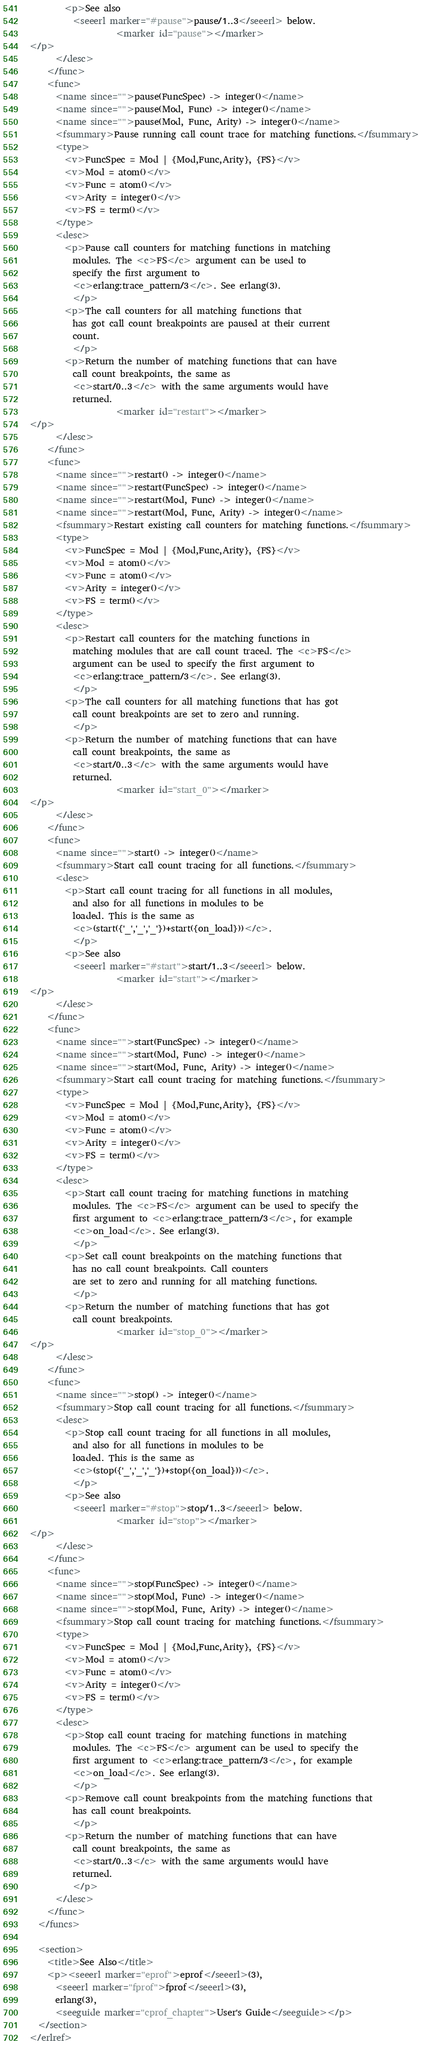Convert code to text. <code><loc_0><loc_0><loc_500><loc_500><_XML_>        <p>See also 
          <seeerl marker="#pause">pause/1..3</seeerl> below.
                    <marker id="pause"></marker>
</p>
      </desc>
    </func>
    <func>
      <name since="">pause(FuncSpec) -> integer()</name>
      <name since="">pause(Mod, Func) -> integer()</name>
      <name since="">pause(Mod, Func, Arity) -> integer()</name>
      <fsummary>Pause running call count trace for matching functions.</fsummary>
      <type>
        <v>FuncSpec = Mod | {Mod,Func,Arity}, {FS}</v>
        <v>Mod = atom()</v>
        <v>Func = atom()</v>
        <v>Arity = integer()</v>
        <v>FS = term()</v>
      </type>
      <desc>
        <p>Pause call counters for matching functions in matching 
          modules. The <c>FS</c> argument can be used to
          specify the first argument to
          <c>erlang:trace_pattern/3</c>. See erlang(3). 
          </p>
        <p>The call counters for all matching functions that
          has got call count breakpoints are paused at their current
          count. 
          </p>
        <p>Return the number of matching functions that can have
          call count breakpoints, the same as
          <c>start/0..3</c> with the same arguments would have
          returned. 
                    <marker id="restart"></marker>
</p>
      </desc>
    </func>
    <func>
      <name since="">restart() -> integer()</name>
      <name since="">restart(FuncSpec) -> integer()</name>
      <name since="">restart(Mod, Func) -> integer()</name>
      <name since="">restart(Mod, Func, Arity) -> integer()</name>
      <fsummary>Restart existing call counters for matching functions.</fsummary>
      <type>
        <v>FuncSpec = Mod | {Mod,Func,Arity}, {FS}</v>
        <v>Mod = atom()</v>
        <v>Func = atom()</v>
        <v>Arity = integer()</v>
        <v>FS = term()</v>
      </type>
      <desc>
        <p>Restart call counters for the matching functions in
          matching modules that are call count traced. The <c>FS</c>
          argument can be used to specify the first argument to
          <c>erlang:trace_pattern/3</c>. See erlang(3).
          </p>
        <p>The call counters for all matching functions that has got
          call count breakpoints are set to zero and running.
          </p>
        <p>Return the number of matching functions that can have
          call count breakpoints, the same as
          <c>start/0..3</c> with the same arguments would have
          returned. 
                    <marker id="start_0"></marker>
</p>
      </desc>
    </func>
    <func>
      <name since="">start() -> integer()</name>
      <fsummary>Start call count tracing for all functions.</fsummary>
      <desc>
        <p>Start call count tracing for all functions in all modules, 
          and also for all functions in modules to be
          loaded. This is the same as 
          <c>(start({'_','_','_'})+start({on_load}))</c>.
          </p>
        <p>See also 
          <seeerl marker="#start">start/1..3</seeerl> below.
                    <marker id="start"></marker>
</p>
      </desc>
    </func>
    <func>
      <name since="">start(FuncSpec) -> integer()</name>
      <name since="">start(Mod, Func) -> integer()</name>
      <name since="">start(Mod, Func, Arity) -> integer()</name>
      <fsummary>Start call count tracing for matching functions.</fsummary>
      <type>
        <v>FuncSpec = Mod | {Mod,Func,Arity}, {FS}</v>
        <v>Mod = atom()</v>
        <v>Func = atom()</v>
        <v>Arity = integer()</v>
        <v>FS = term()</v>
      </type>
      <desc>
        <p>Start call count tracing for matching functions in matching 
          modules. The <c>FS</c> argument can be used to specify the
          first argument to <c>erlang:trace_pattern/3</c>, for example
          <c>on_load</c>. See erlang(3). 
          </p>
        <p>Set call count breakpoints on the matching functions that
          has no call count breakpoints. Call counters 
          are set to zero and running for all matching functions.
          </p>
        <p>Return the number of matching functions that has got
          call count breakpoints.
                    <marker id="stop_0"></marker>
</p>
      </desc>
    </func>
    <func>
      <name since="">stop() -> integer()</name>
      <fsummary>Stop call count tracing for all functions.</fsummary>
      <desc>
        <p>Stop call count tracing for all functions in all modules, 
          and also for all functions in modules to be
          loaded. This is the same as 
          <c>(stop({'_','_','_'})+stop({on_load}))</c>.
          </p>
        <p>See also 
          <seeerl marker="#stop">stop/1..3</seeerl> below.
                    <marker id="stop"></marker>
</p>
      </desc>
    </func>
    <func>
      <name since="">stop(FuncSpec) -> integer()</name>
      <name since="">stop(Mod, Func) -> integer()</name>
      <name since="">stop(Mod, Func, Arity) -> integer()</name>
      <fsummary>Stop call count tracing for matching functions.</fsummary>
      <type>
        <v>FuncSpec = Mod | {Mod,Func,Arity}, {FS}</v>
        <v>Mod = atom()</v>
        <v>Func = atom()</v>
        <v>Arity = integer()</v>
        <v>FS = term()</v>
      </type>
      <desc>
        <p>Stop call count tracing for matching functions in matching 
          modules. The <c>FS</c> argument can be used to specify the
          first argument to <c>erlang:trace_pattern/3</c>, for example
          <c>on_load</c>. See erlang(3). 
          </p>
        <p>Remove call count breakpoints from the matching functions that
          has call count breakpoints.
          </p>
        <p>Return the number of matching functions that can have
          call count breakpoints, the same as
          <c>start/0..3</c> with the same arguments would have
          returned. 
          </p>
      </desc>
    </func>
  </funcs>

  <section>
    <title>See Also</title>
    <p><seeerl marker="eprof">eprof</seeerl>(3), 
      <seeerl marker="fprof">fprof</seeerl>(3), 
      erlang(3), 
      <seeguide marker="cprof_chapter">User's Guide</seeguide></p>
  </section>
</erlref>

</code> 